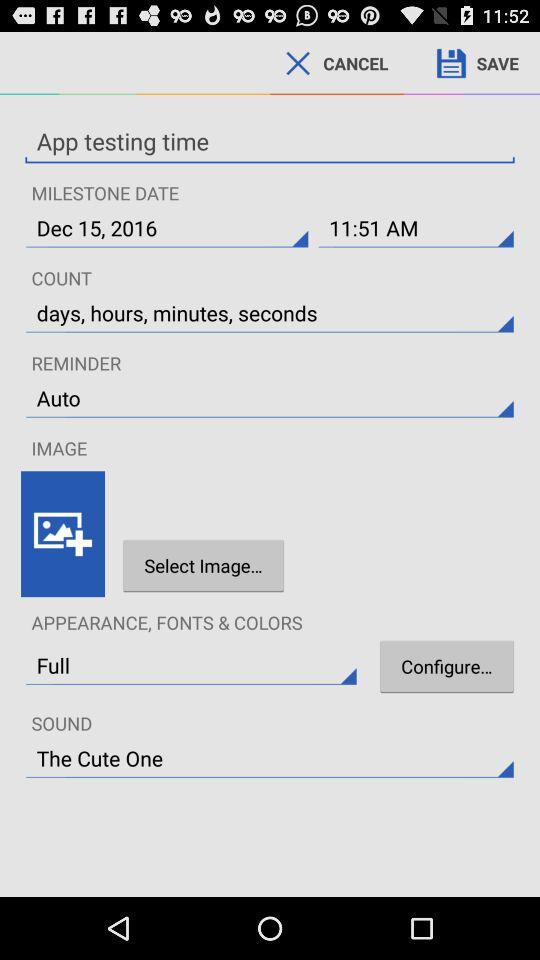What option is selected in "COUNT"? The selected option is "days, hours, minutes, seconds". 